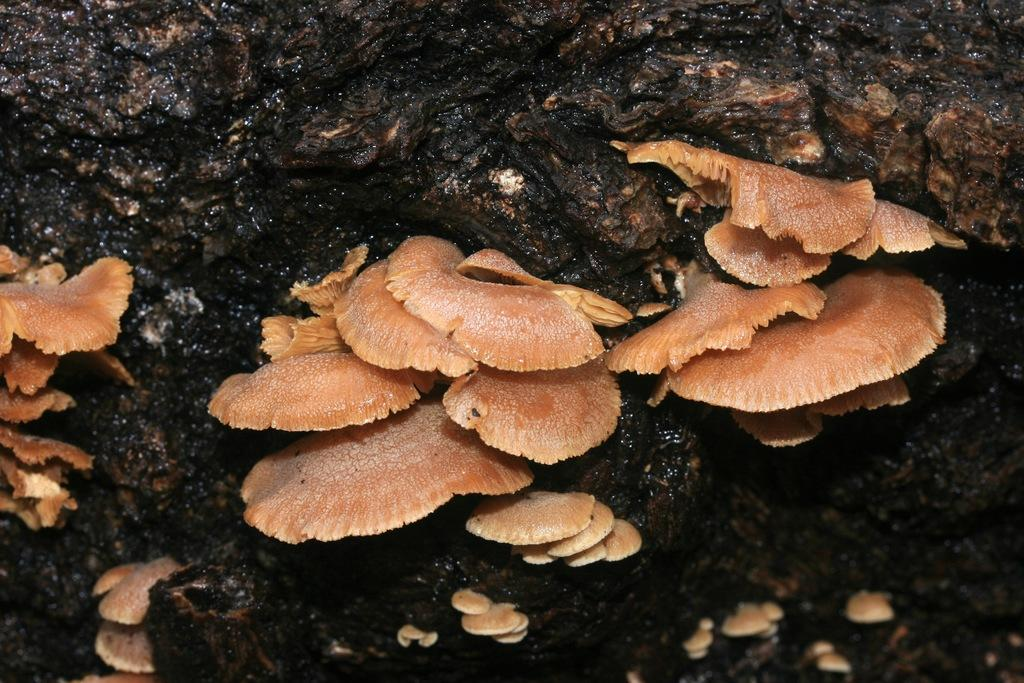What type of natural object can be seen in the image? There is a rock in the image. What other natural objects are present in the image? There are mushrooms in the image. What color is the scarf that the rock is wearing in the image? There is no scarf present in the image, as rocks do not wear clothing. What type of medical procedure is being performed on the mushrooms in the image? There is no operation or medical procedure being performed on the mushrooms in the image; they are simply growing in their natural environment. 